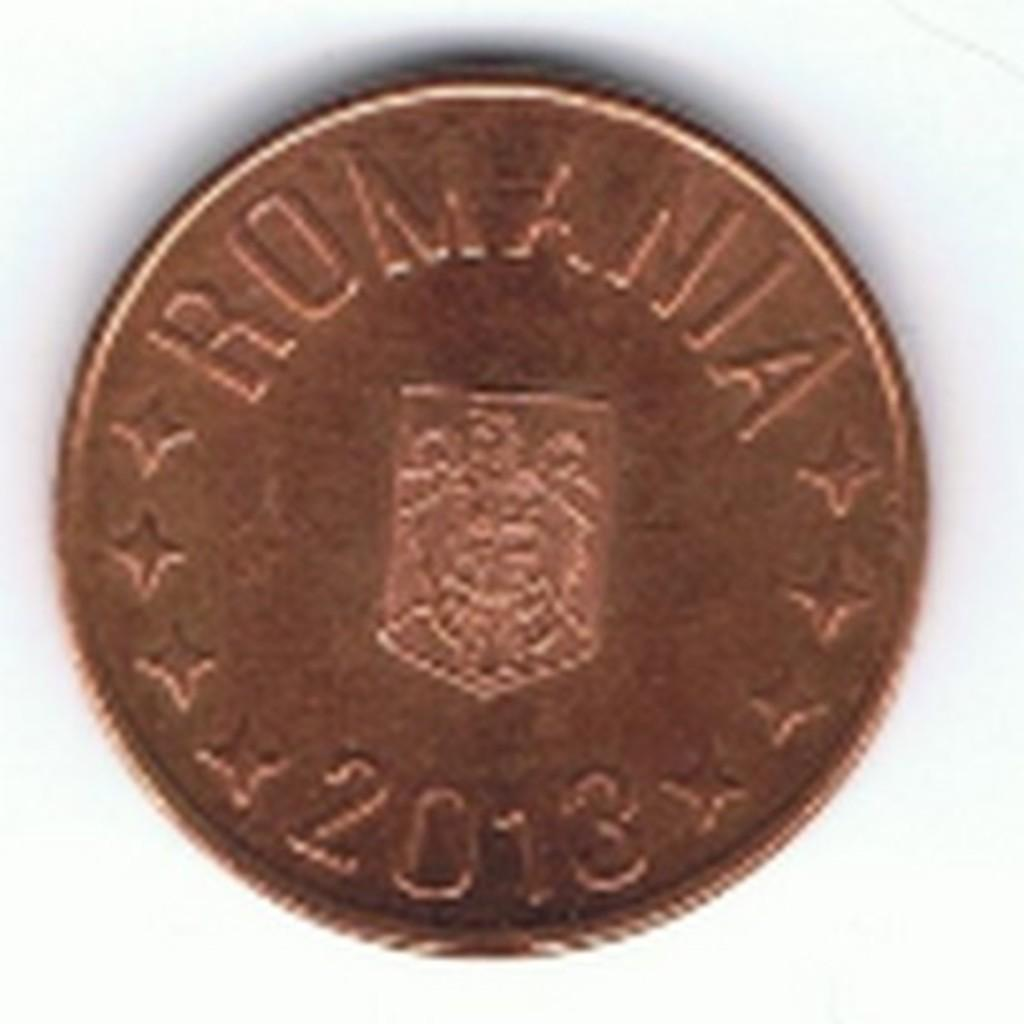<image>
Give a short and clear explanation of the subsequent image. The copper coin in the image has the year 2013 on it 